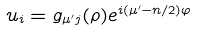Convert formula to latex. <formula><loc_0><loc_0><loc_500><loc_500>u _ { i } = g _ { \mu ^ { \prime } j } ( \rho ) e ^ { i ( \mu ^ { \prime } - n / 2 ) \varphi }</formula> 